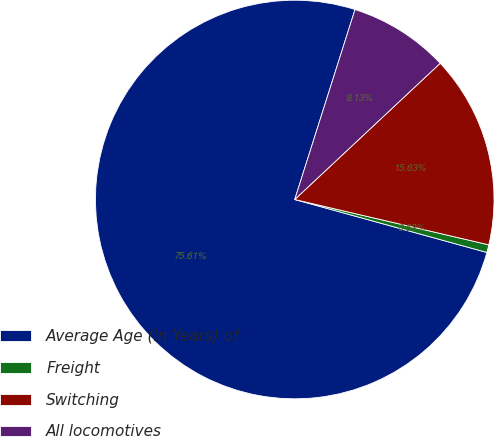<chart> <loc_0><loc_0><loc_500><loc_500><pie_chart><fcel>Average Age (in Years) of<fcel>Freight<fcel>Switching<fcel>All locomotives<nl><fcel>75.61%<fcel>0.63%<fcel>15.63%<fcel>8.13%<nl></chart> 